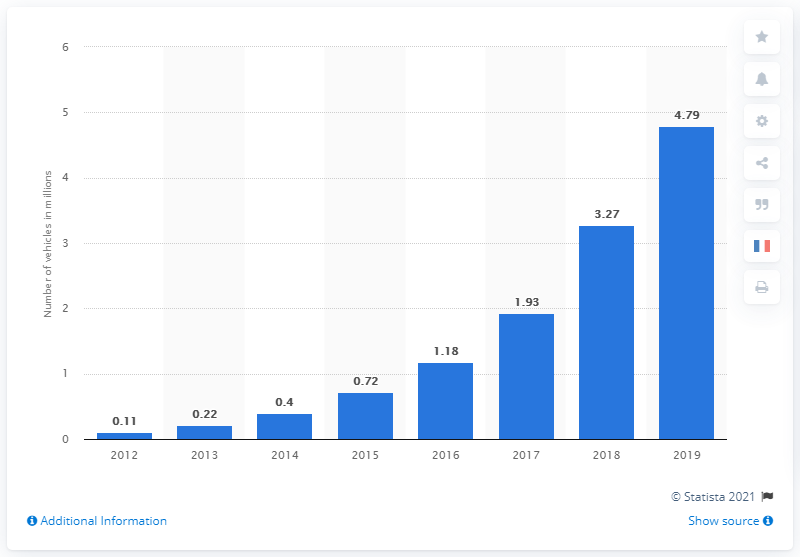Highlight a few significant elements in this photo. According to data from 2019, there were approximately 4.79 million battery electric vehicles in use globally. 